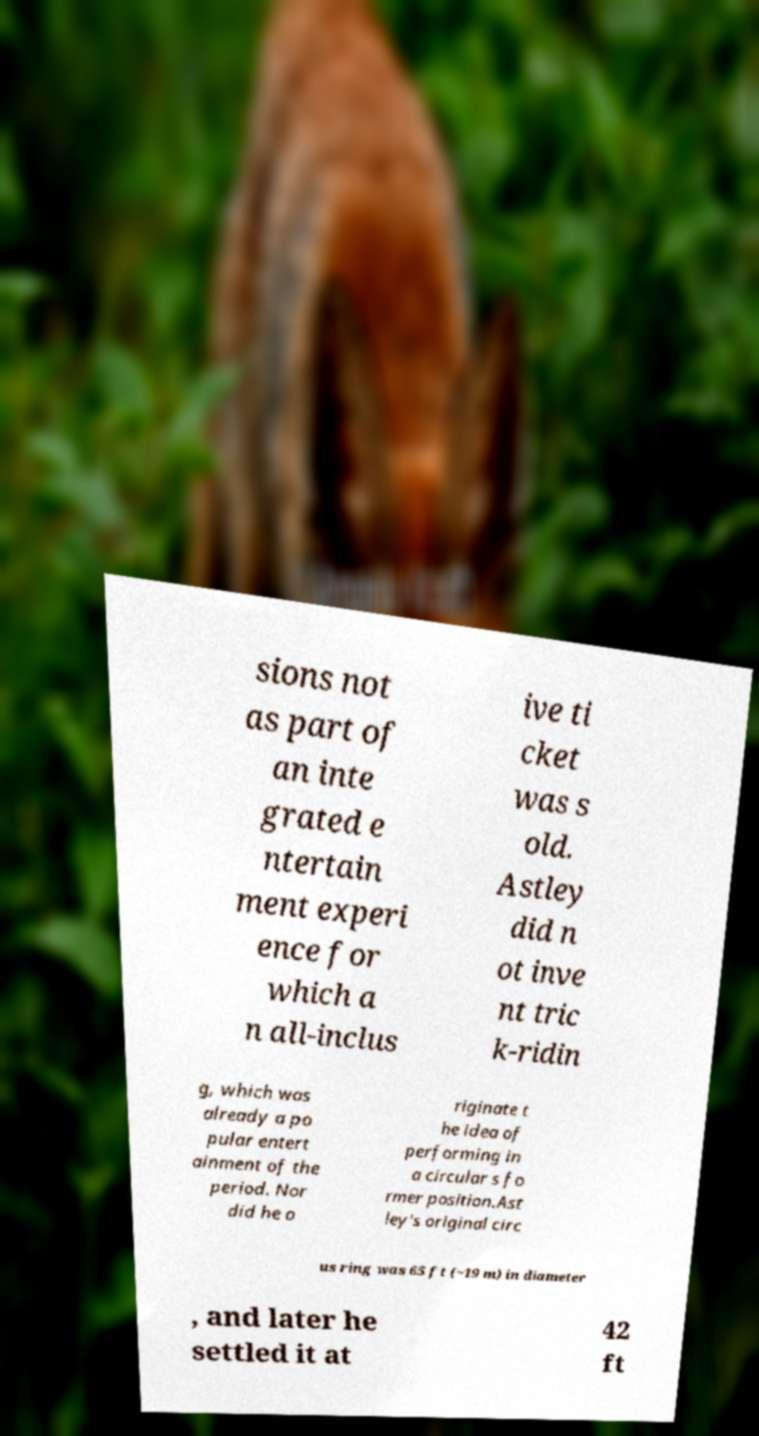Please identify and transcribe the text found in this image. sions not as part of an inte grated e ntertain ment experi ence for which a n all-inclus ive ti cket was s old. Astley did n ot inve nt tric k-ridin g, which was already a po pular entert ainment of the period. Nor did he o riginate t he idea of performing in a circular s fo rmer position.Ast ley's original circ us ring was 65 ft (~19 m) in diameter , and later he settled it at 42 ft 